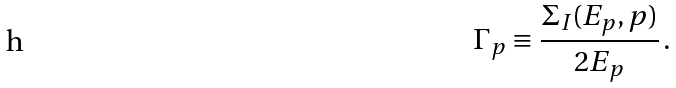<formula> <loc_0><loc_0><loc_500><loc_500>\Gamma _ { p } \equiv \frac { \Sigma _ { I } ( E _ { p } , { p } ) } { 2 E _ { p } } \, .</formula> 